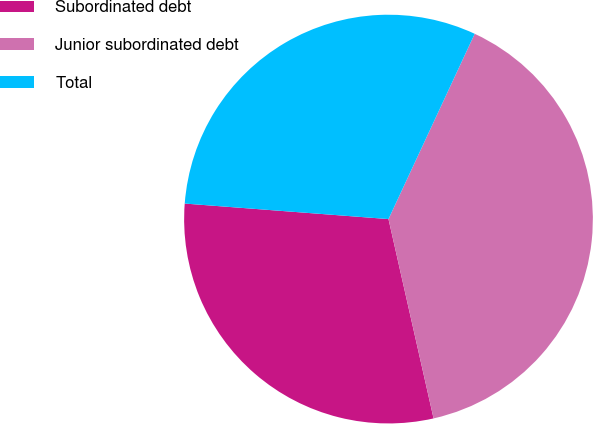<chart> <loc_0><loc_0><loc_500><loc_500><pie_chart><fcel>Subordinated debt<fcel>Junior subordinated debt<fcel>Total<nl><fcel>29.75%<fcel>39.53%<fcel>30.72%<nl></chart> 